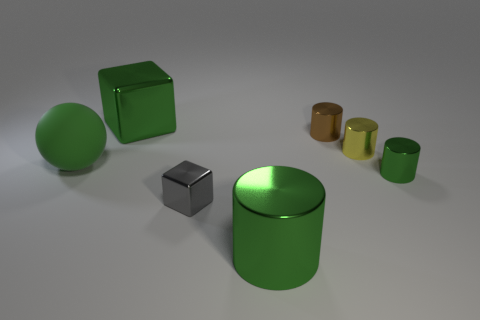There is a small cylinder that is in front of the large matte sphere; is it the same color as the matte ball? The small cylinder in front of the large matte sphere has a similar shade but is not the same color. The cylinder has a slightly more yellow hue compared to the sphere, indicating a variation in color despite their similarities. 